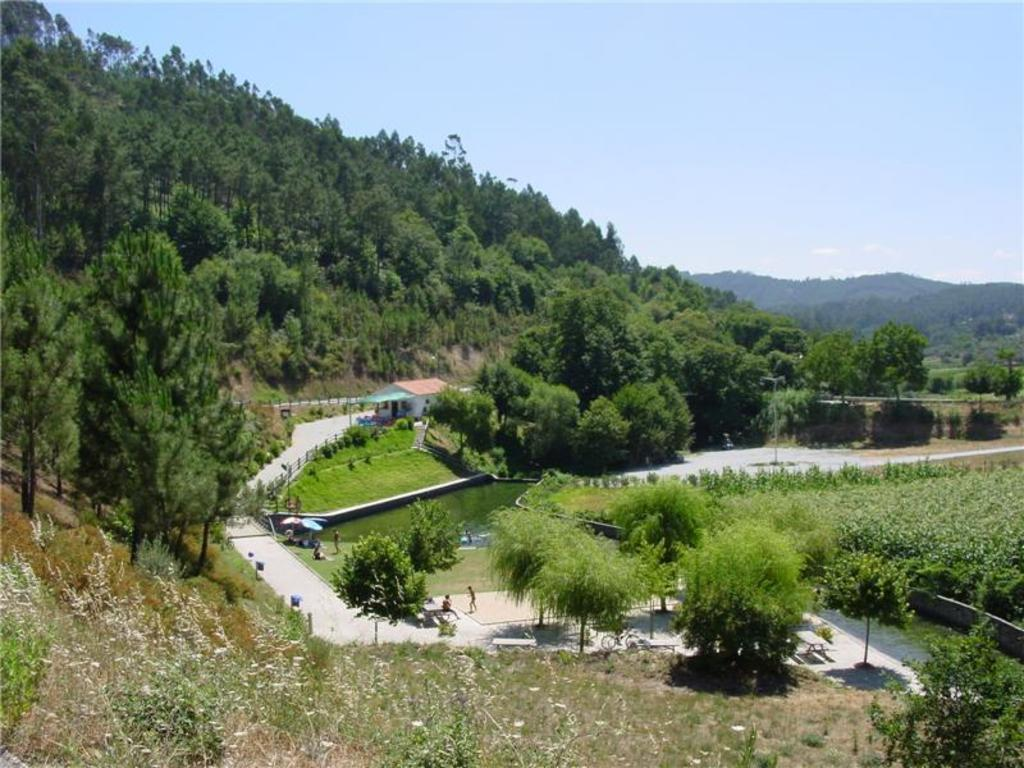What is located in the center of the image? There are trees in the center of the image. What type of vegetation can be seen in the image? There is grass in the image. What can be seen in the background of the image? There are mountains in the background of the image. What type of vacation is being advertised in the image? There is no indication of a vacation being advertised in the image; it simply shows trees, grass, and mountains. What role does the spoon play in the image? There is no spoon present in the image. 